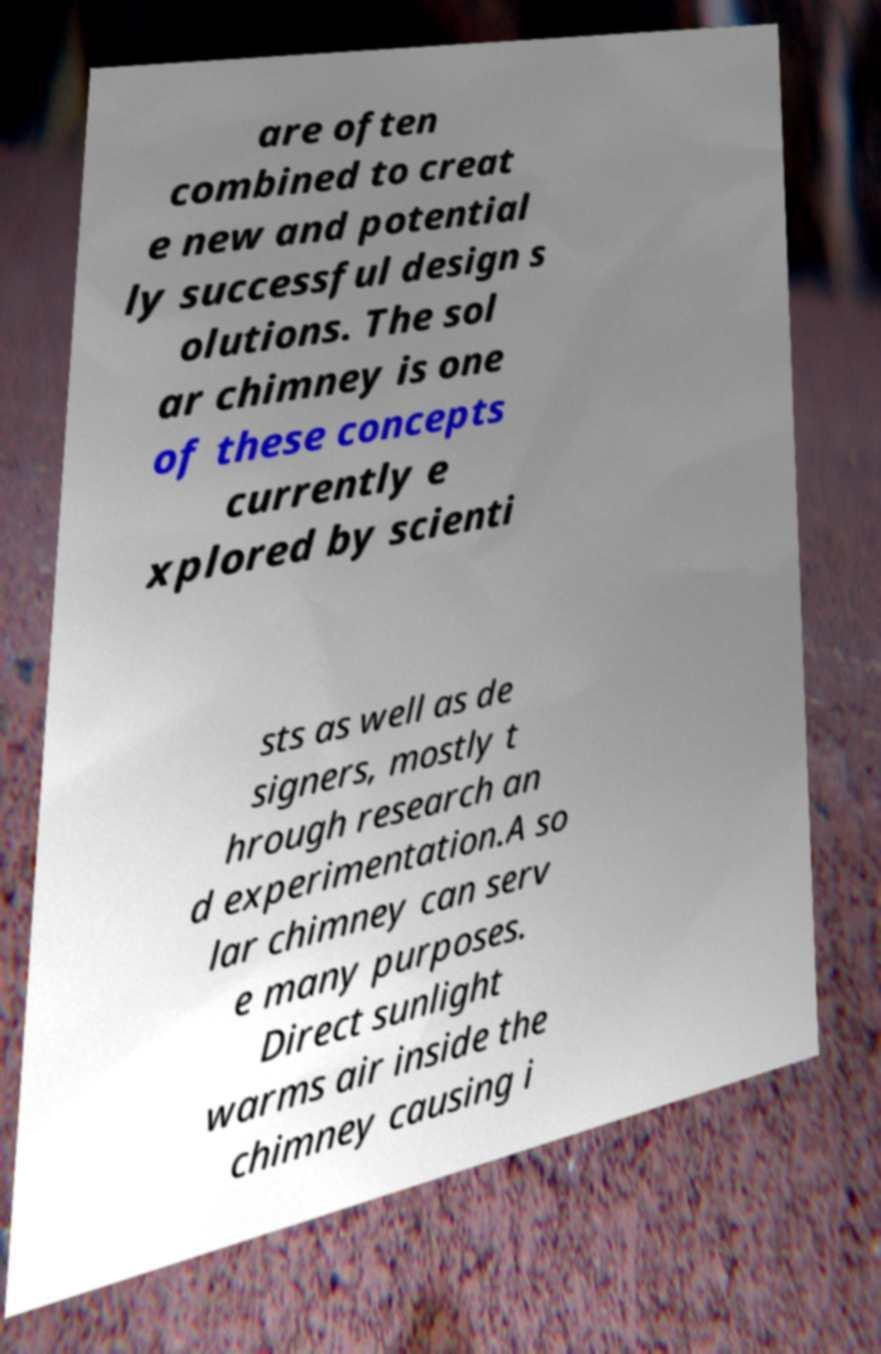Can you read and provide the text displayed in the image?This photo seems to have some interesting text. Can you extract and type it out for me? are often combined to creat e new and potential ly successful design s olutions. The sol ar chimney is one of these concepts currently e xplored by scienti sts as well as de signers, mostly t hrough research an d experimentation.A so lar chimney can serv e many purposes. Direct sunlight warms air inside the chimney causing i 